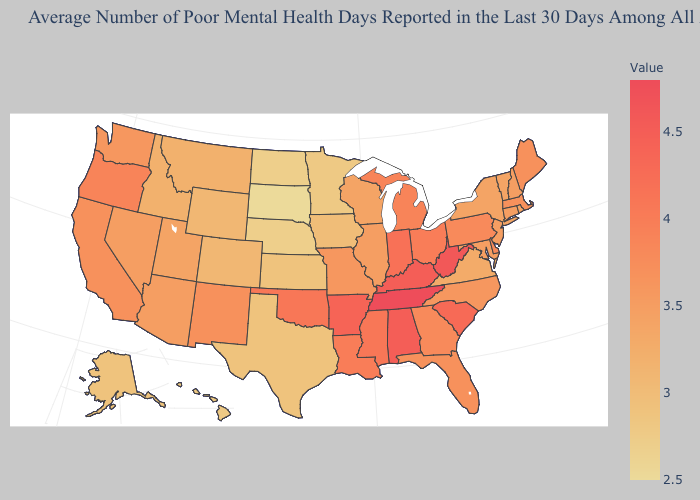Among the states that border Minnesota , which have the lowest value?
Give a very brief answer. South Dakota. Does Maine have a lower value than Virginia?
Quick response, please. No. Does South Dakota have the lowest value in the USA?
Be succinct. Yes. Does Tennessee have the highest value in the USA?
Be succinct. Yes. Does Kentucky have a higher value than Idaho?
Be succinct. Yes. Does Maryland have a higher value than Montana?
Quick response, please. Yes. Among the states that border Virginia , does Maryland have the highest value?
Write a very short answer. No. Among the states that border Vermont , which have the highest value?
Short answer required. Massachusetts. Which states have the highest value in the USA?
Answer briefly. Tennessee. 